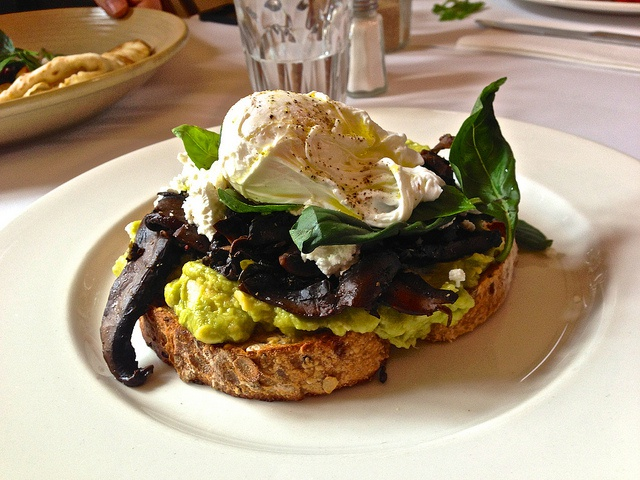Describe the objects in this image and their specific colors. I can see dining table in ivory, black, olive, and gray tones, sandwich in black, olive, and maroon tones, bowl in black, olive, maroon, and tan tones, cup in black, darkgray, and gray tones, and knife in black, gray, darkgray, and brown tones in this image. 